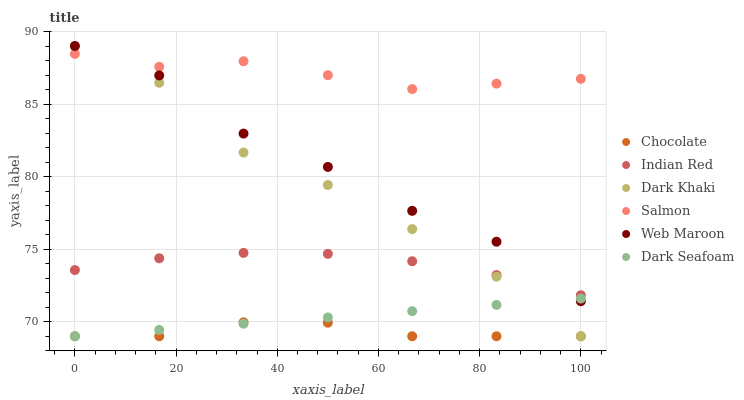Does Chocolate have the minimum area under the curve?
Answer yes or no. Yes. Does Salmon have the maximum area under the curve?
Answer yes or no. Yes. Does Web Maroon have the minimum area under the curve?
Answer yes or no. No. Does Web Maroon have the maximum area under the curve?
Answer yes or no. No. Is Dark Seafoam the smoothest?
Answer yes or no. Yes. Is Web Maroon the roughest?
Answer yes or no. Yes. Is Chocolate the smoothest?
Answer yes or no. No. Is Chocolate the roughest?
Answer yes or no. No. Does Chocolate have the lowest value?
Answer yes or no. Yes. Does Web Maroon have the lowest value?
Answer yes or no. No. Does Dark Khaki have the highest value?
Answer yes or no. Yes. Does Chocolate have the highest value?
Answer yes or no. No. Is Chocolate less than Web Maroon?
Answer yes or no. Yes. Is Indian Red greater than Chocolate?
Answer yes or no. Yes. Does Salmon intersect Dark Khaki?
Answer yes or no. Yes. Is Salmon less than Dark Khaki?
Answer yes or no. No. Is Salmon greater than Dark Khaki?
Answer yes or no. No. Does Chocolate intersect Web Maroon?
Answer yes or no. No. 